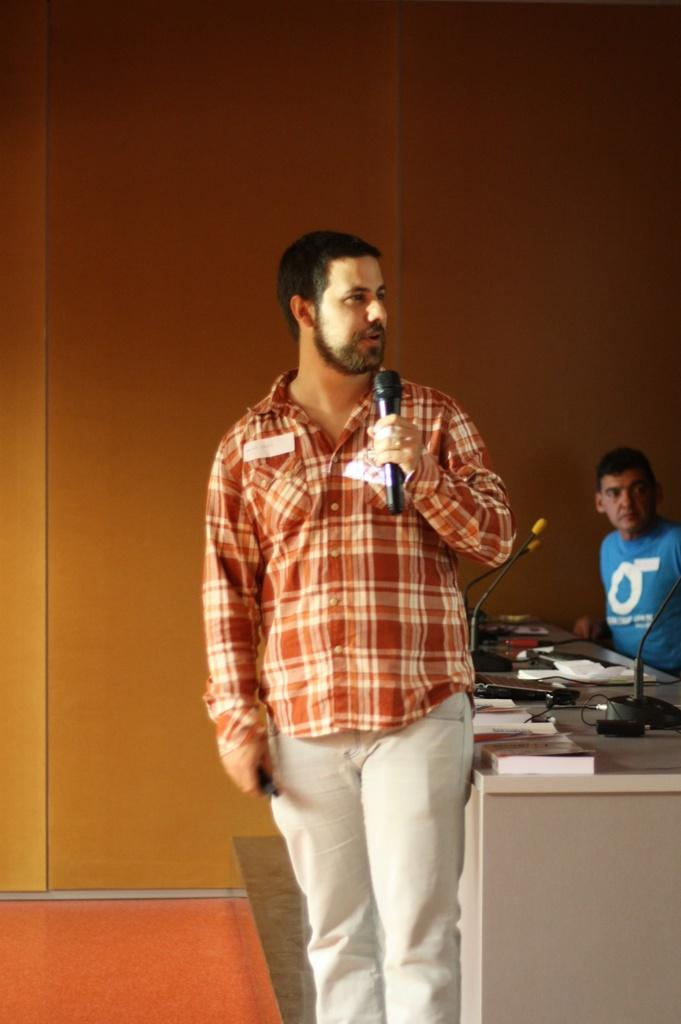What is the man in the image doing? The man is standing and holding a microphone. Who else is present in the image? There is a person sitting in the image. What objects are on the table? There are papers and microphones on the table. What type of quill is the man using to write on the papers in the image? There is no quill present in the image. The man is holding a microphone, not a quill. 